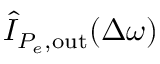<formula> <loc_0><loc_0><loc_500><loc_500>\hat { I } _ { P _ { e } , o u t } ( \Delta \omega )</formula> 